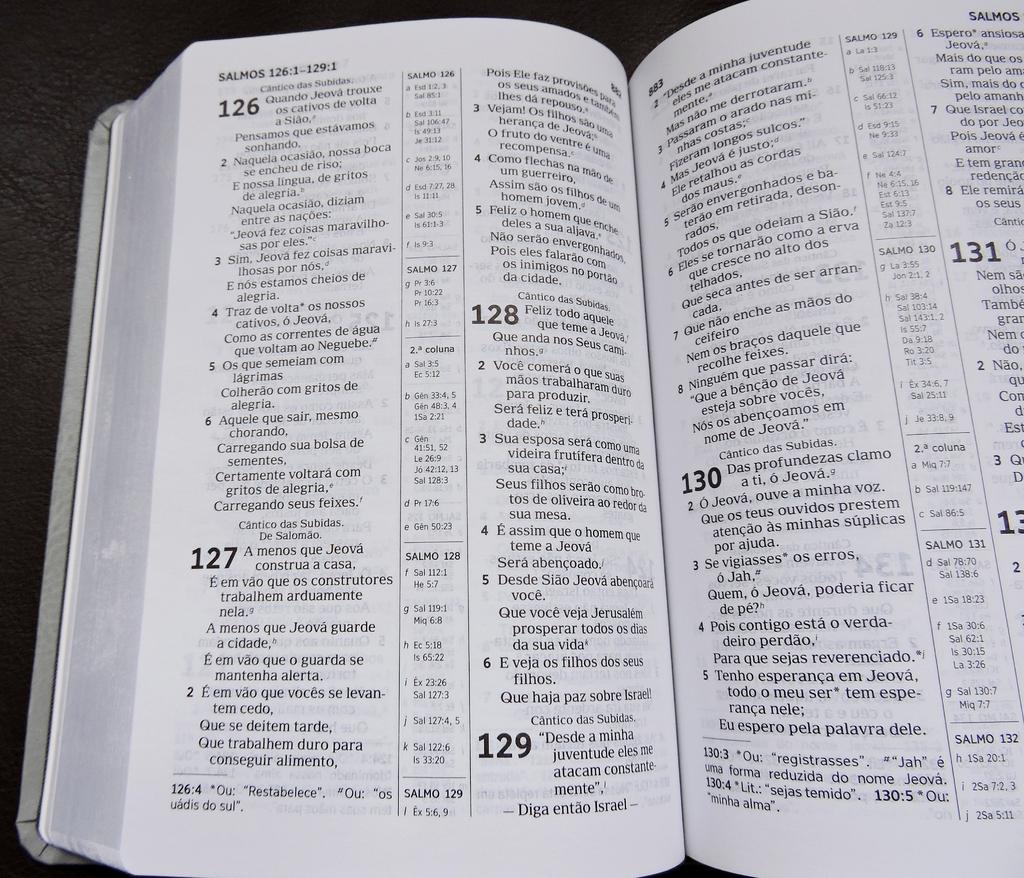What book of the bible is this?
Offer a terse response. Salmos. What 4 large bold number are on the left page?
Give a very brief answer. 126, 127, 128, 129. 